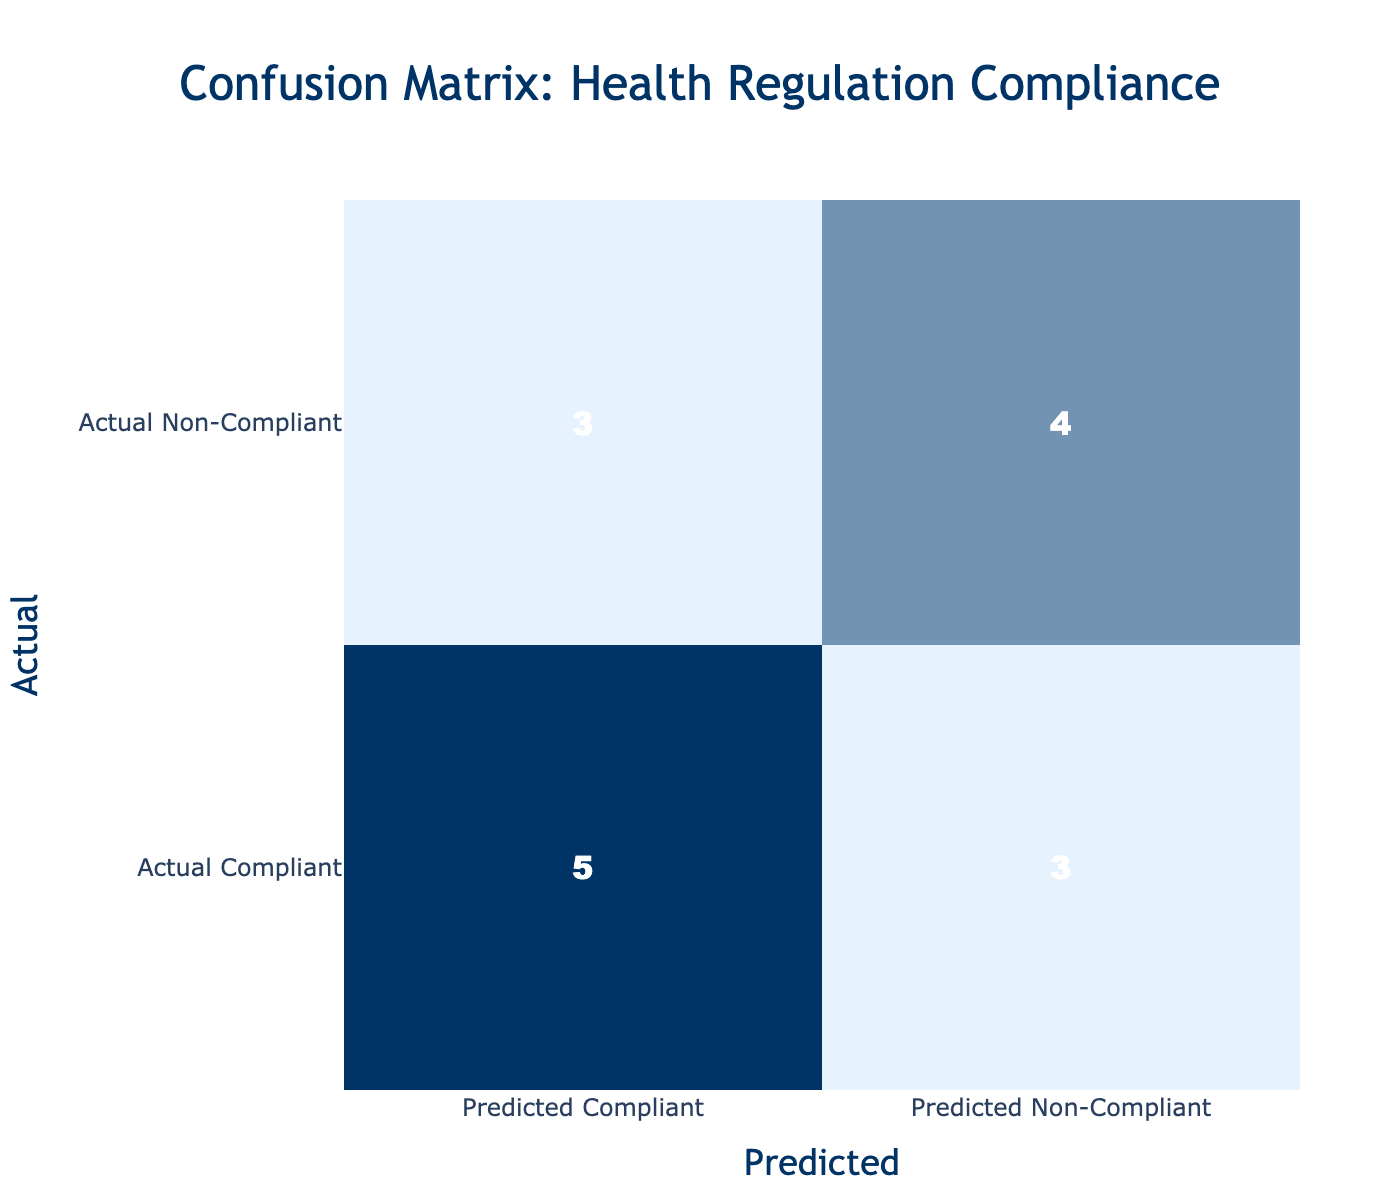What is the number of true compliant establishments that were predicted to be compliant? From the confusion matrix, we look for the intersection of "Actual Compliant" and "Predicted Compliant," which is the top left cell. There are 5 establishments in this category.
Answer: 5 How many establishments were predicted to be non-compliant? To find this number, we sum the values in the "Predicted Non-Compliant" column. This includes 2 from actual compliant and 4 from actual non-compliant, totaling 6.
Answer: 6 What is the total number of establishments assessed? We calculate the total by summing all values in the confusion matrix. Adding the numbers gives: 5 (true positive) + 2 (false negative) + 1 (false positive) + 4 (true negative) = 12.
Answer: 12 Is it true that more establishments were correctly predicted as non-compliant than those incorrectly predicted as compliant? We have 4 establishments that were correctly predicted as non-compliant (true negatives) compared to 3 establishments that were incorrectly predicted (2 false negatives and 1 false positive). Thus, the statement is true.
Answer: Yes What is the difference between the number of compliant establishments predicted as non-compliant and those predicted as compliant? We find the number of establishments predicted as non-compliant from the "Compliant" row, which is 2, and those predicted as compliant, which are 5. The difference is 5 - 2 = 3.
Answer: 3 What is the percentage of establishments that were correctly identified as compliant? For the percentage, we take the number of true compliant establishments (5) and divide it by the total number (12), then multiply by 100. This gives us (5/12) * 100 = approximately 41.67%.
Answer: 41.67% How many non-compliant establishments were incorrectly predicted as compliant? This number corresponds to the bottom left cell of the confusion matrix, where actual non-compliant establishments were predicted to be compliant, which is 1 establishment.
Answer: 1 What is the average number of compliant establishments predicted in both the compliant and non-compliant actual categories? In the actual compliant category, 5 were predicted as compliant, and in the non-compliant category, 4 were predicted as compliant. The average is (5 + 0) / 2 = 2.5.
Answer: 2.5 